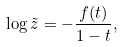<formula> <loc_0><loc_0><loc_500><loc_500>\log \tilde { z } = - \frac { f ( t ) } { 1 - t } ,</formula> 